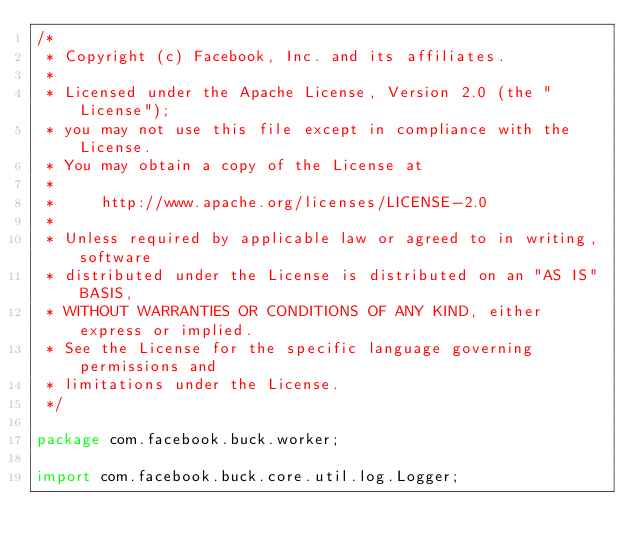<code> <loc_0><loc_0><loc_500><loc_500><_Java_>/*
 * Copyright (c) Facebook, Inc. and its affiliates.
 *
 * Licensed under the Apache License, Version 2.0 (the "License");
 * you may not use this file except in compliance with the License.
 * You may obtain a copy of the License at
 *
 *     http://www.apache.org/licenses/LICENSE-2.0
 *
 * Unless required by applicable law or agreed to in writing, software
 * distributed under the License is distributed on an "AS IS" BASIS,
 * WITHOUT WARRANTIES OR CONDITIONS OF ANY KIND, either express or implied.
 * See the License for the specific language governing permissions and
 * limitations under the License.
 */

package com.facebook.buck.worker;

import com.facebook.buck.core.util.log.Logger;</code> 